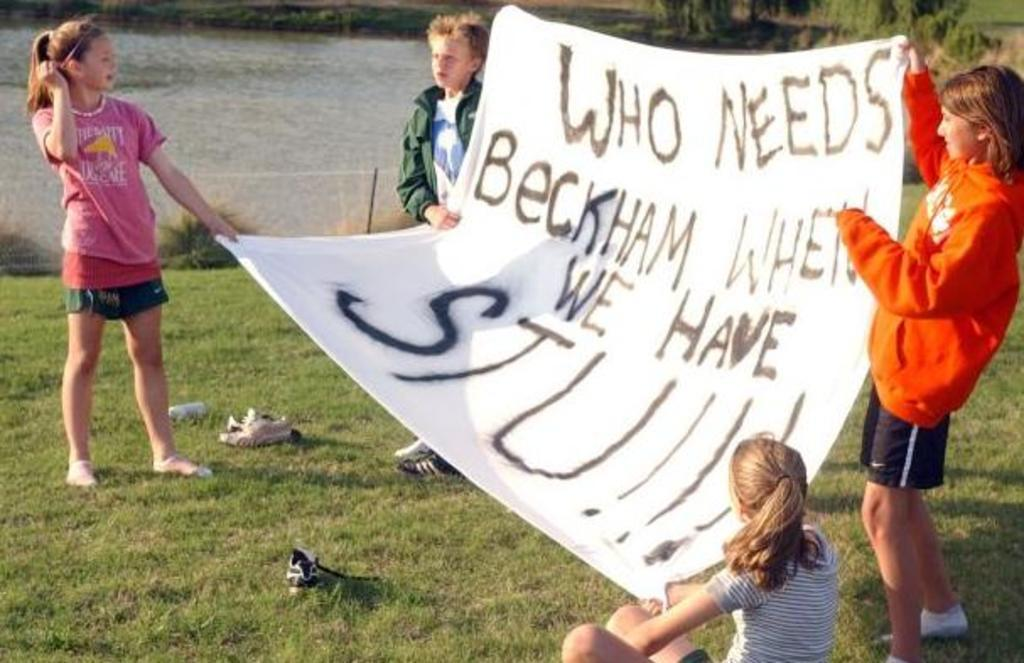How many children are present in the image? There are four children in the image. What are the children holding in the image? The children are holding a banner in the image. What type of terrain is visible in the image? There is grass in the image, which suggests a grassy area. What type of natural feature can be seen in the image? There is a lake in the image. Are there any plants visible in the image? Yes, there is a plant in the image. What type of loaf can be seen floating on the lake in the image? There is no loaf present in the image, and therefore no such object can be seen floating on the lake. How does the button on the banner increase the visibility of the message in the image? There is no button on the banner in the image, so it cannot be used to increase the visibility of the message. 